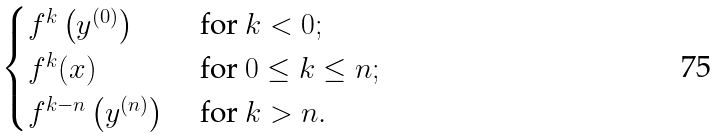Convert formula to latex. <formula><loc_0><loc_0><loc_500><loc_500>\begin{cases} f ^ { k } \left ( y ^ { ( 0 ) } \right ) & \text { for } k < 0 ; \\ f ^ { k } ( x ) & \text { for } 0 \leq k \leq n ; \\ f ^ { k - n } \left ( y ^ { ( n ) } \right ) & \text { for } k > n . \end{cases}</formula> 